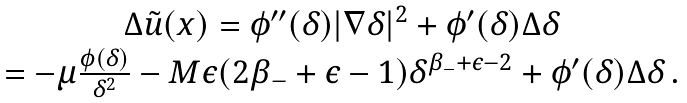<formula> <loc_0><loc_0><loc_500><loc_500>\begin{array} { c } \Delta \tilde { u } ( x ) = \phi ^ { \prime \prime } ( \delta ) | \nabla \delta | ^ { 2 } + \phi ^ { \prime } ( \delta ) \Delta \delta \\ = - \mu \frac { \phi ( \delta ) } { \delta ^ { 2 } } - M \epsilon ( 2 \beta _ { - } + \epsilon - 1 ) \delta ^ { \beta _ { - } + \epsilon - 2 } + \phi ^ { \prime } ( \delta ) \Delta \delta \, . \end{array}</formula> 